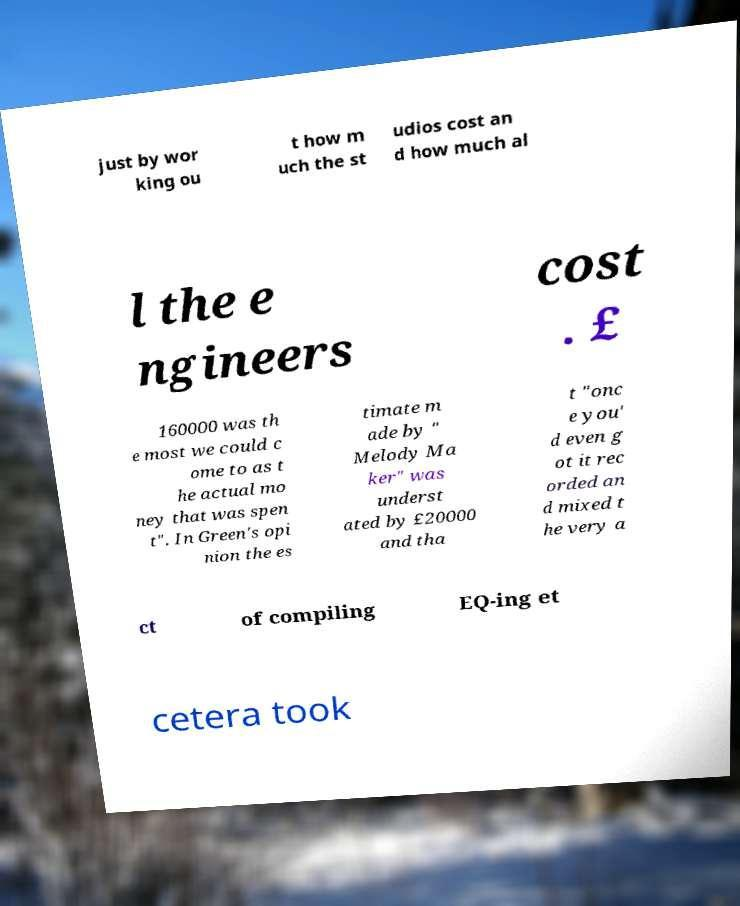I need the written content from this picture converted into text. Can you do that? just by wor king ou t how m uch the st udios cost an d how much al l the e ngineers cost . £ 160000 was th e most we could c ome to as t he actual mo ney that was spen t". In Green's opi nion the es timate m ade by " Melody Ma ker" was underst ated by £20000 and tha t "onc e you' d even g ot it rec orded an d mixed t he very a ct of compiling EQ-ing et cetera took 